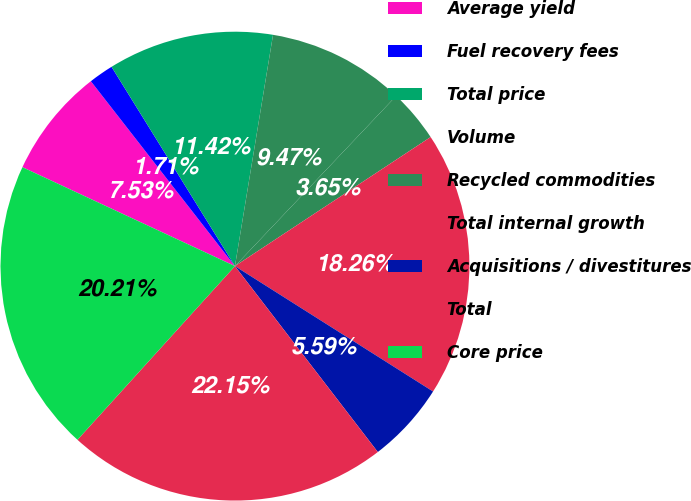Convert chart. <chart><loc_0><loc_0><loc_500><loc_500><pie_chart><fcel>Average yield<fcel>Fuel recovery fees<fcel>Total price<fcel>Volume<fcel>Recycled commodities<fcel>Total internal growth<fcel>Acquisitions / divestitures<fcel>Total<fcel>Core price<nl><fcel>7.53%<fcel>1.71%<fcel>11.42%<fcel>9.47%<fcel>3.65%<fcel>18.26%<fcel>5.59%<fcel>22.15%<fcel>20.21%<nl></chart> 